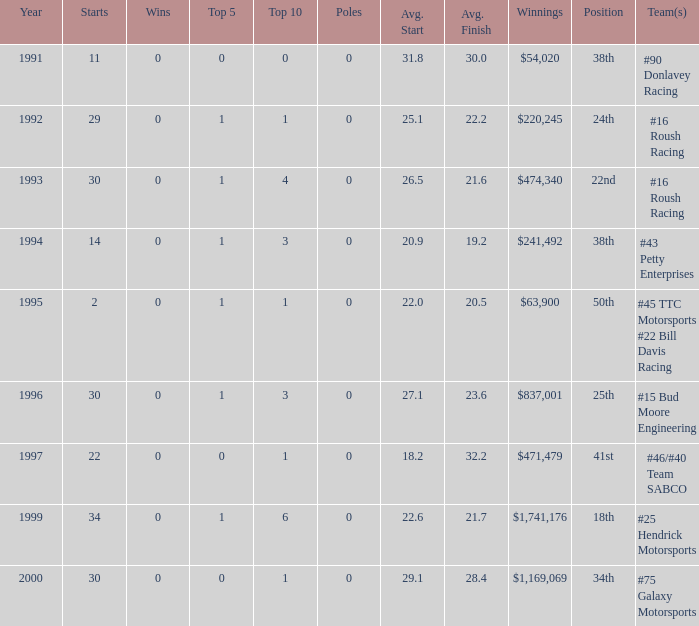When the winnings reached $1,741,176, what position did it hold in the top 10? 6.0. 